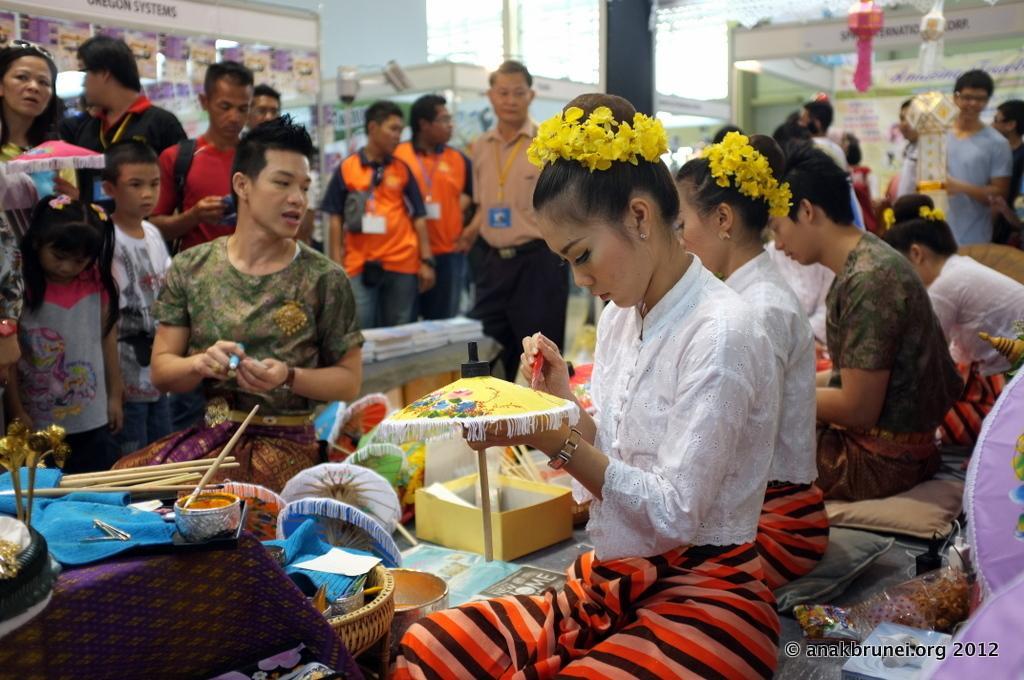Describe this image in one or two sentences. In this image, we can see a group of people. Few people are standing and sitting. Few people are holding some objects. Here we can see box, small umbrellas, sticks. Top of the image, we can see wall, few stalls, decorative items. Right side bottom corner, there is a watermark in the image. 